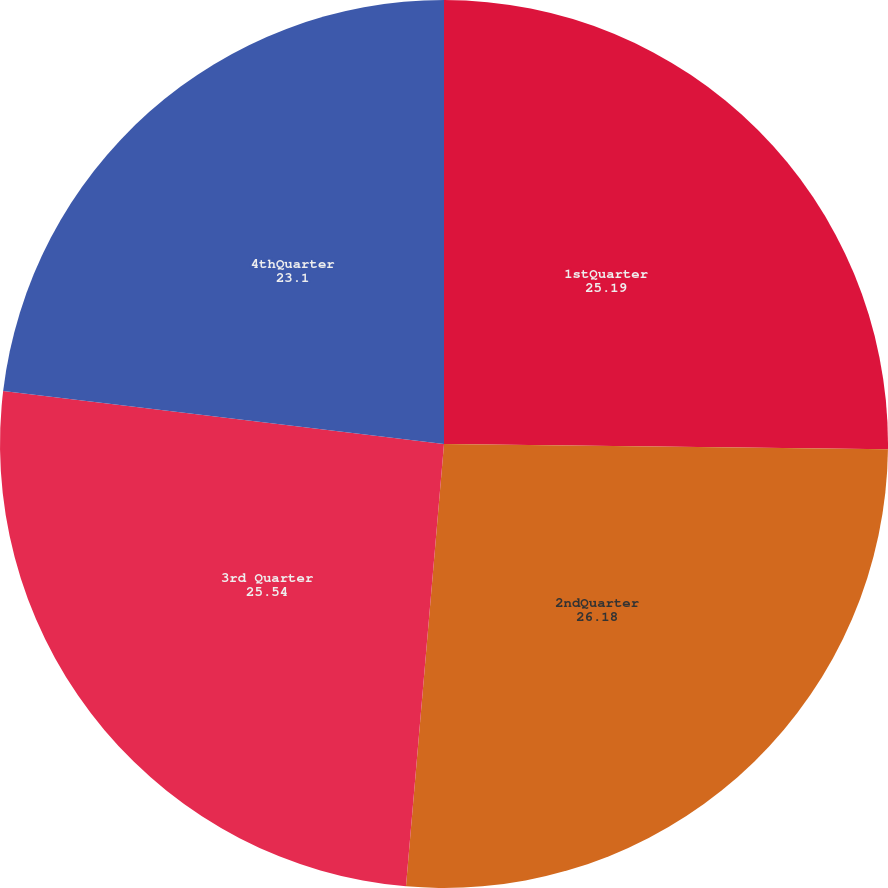<chart> <loc_0><loc_0><loc_500><loc_500><pie_chart><fcel>1stQuarter<fcel>2ndQuarter<fcel>3rd Quarter<fcel>4thQuarter<nl><fcel>25.19%<fcel>26.18%<fcel>25.54%<fcel>23.1%<nl></chart> 